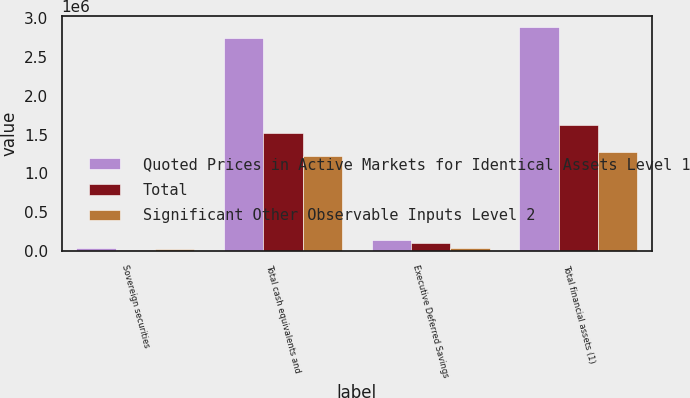Convert chart. <chart><loc_0><loc_0><loc_500><loc_500><stacked_bar_chart><ecel><fcel>Sovereign securities<fcel>Total cash equivalents and<fcel>Executive Deferred Savings<fcel>Total financial assets (1)<nl><fcel>Quoted Prices in Active Markets for Identical Assets Level 1<fcel>33805<fcel>2.75001e+06<fcel>136461<fcel>2.89049e+06<nl><fcel>Total<fcel>13559<fcel>1.52298e+06<fcel>96180<fcel>1.61916e+06<nl><fcel>Significant Other Observable Inputs Level 2<fcel>20246<fcel>1.22703e+06<fcel>40281<fcel>1.27132e+06<nl></chart> 